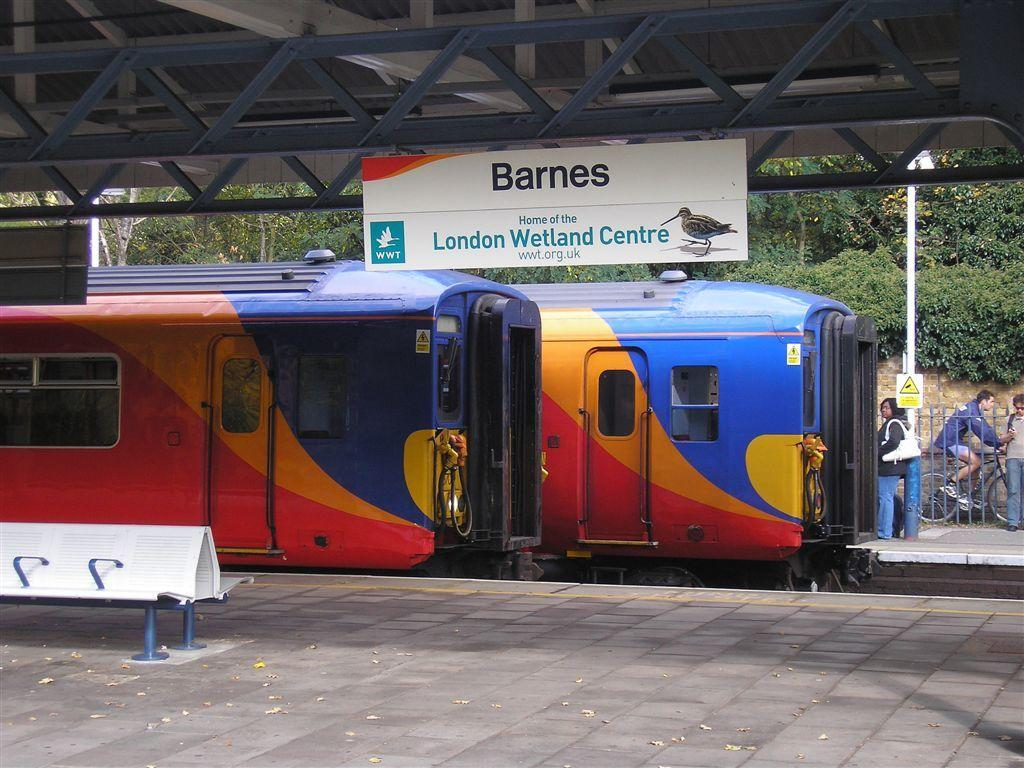Provide a one-sentence caption for the provided image. A train with the banner Barnes and home of the London Wetland Centre. 